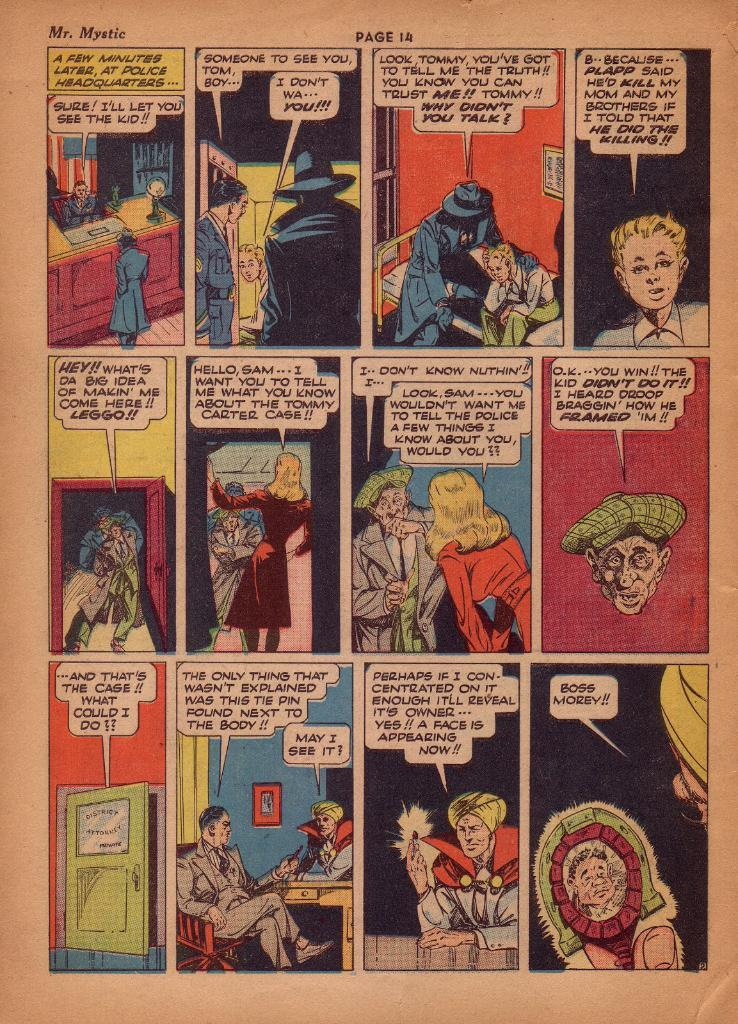<image>
Create a compact narrative representing the image presented. A comic book page features a character named Mr. Mystic. 